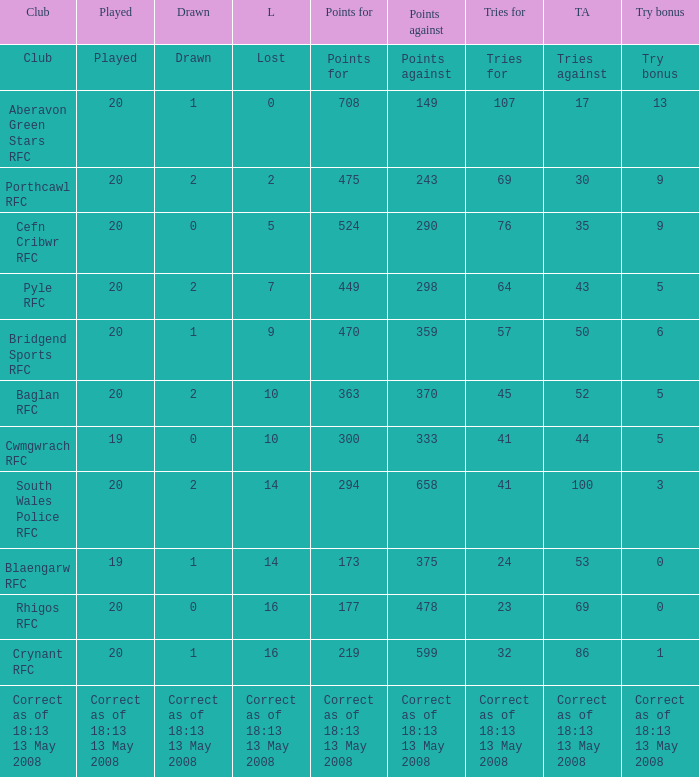What is the lost when the try bonus is 5, and points against is 298? 7.0. 